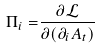<formula> <loc_0><loc_0><loc_500><loc_500>\Pi _ { i } = & \frac { \partial \mathcal { L } } { \partial ( \partial _ { i } A _ { t } ) }</formula> 